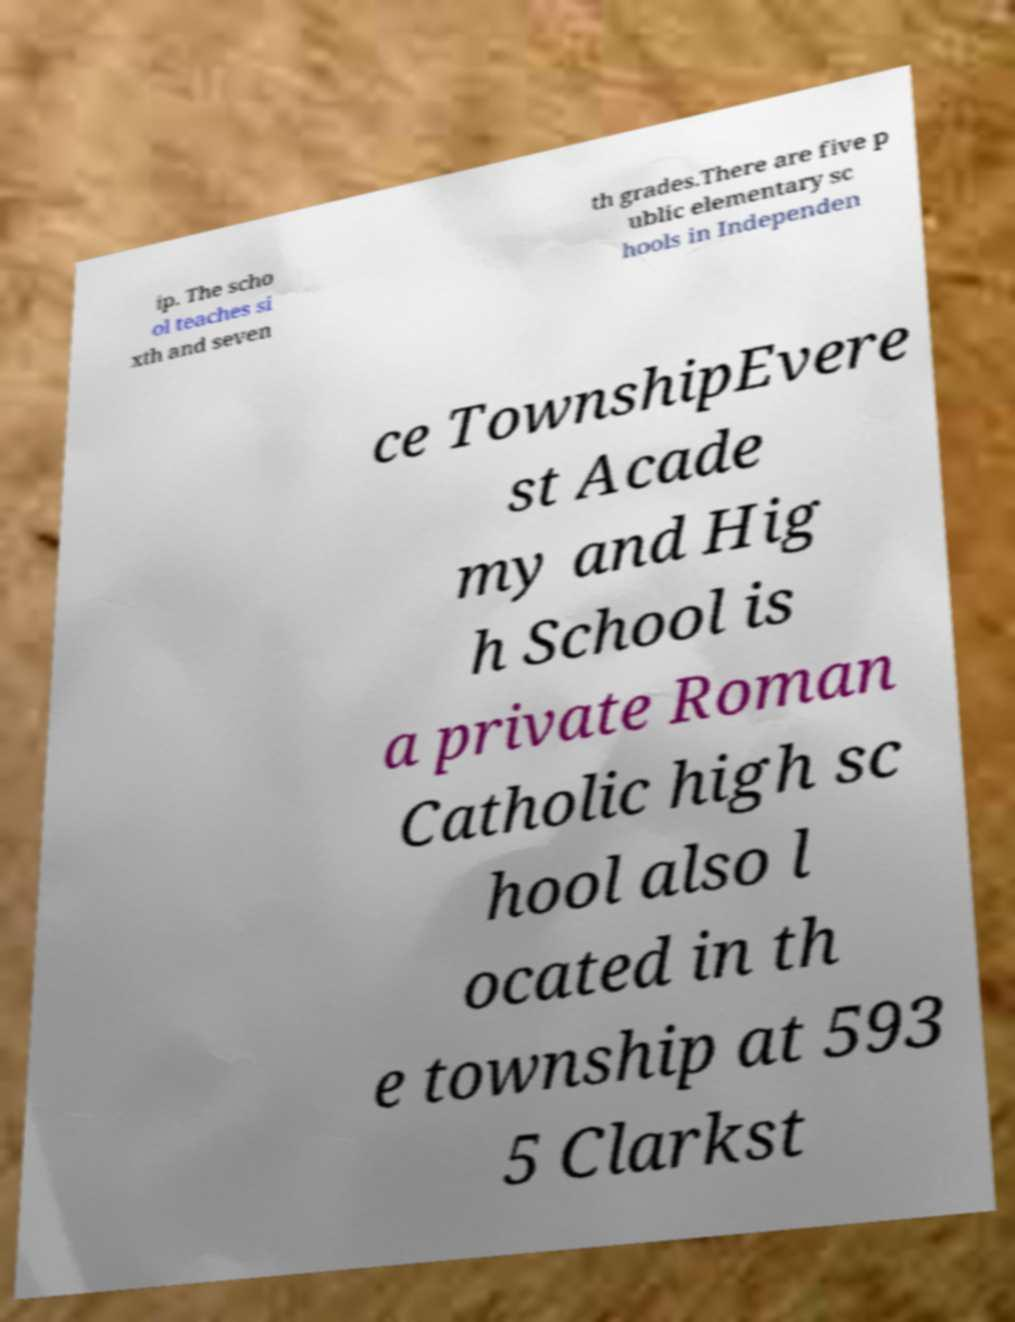Please read and relay the text visible in this image. What does it say? ip. The scho ol teaches si xth and seven th grades.There are five p ublic elementary sc hools in Independen ce TownshipEvere st Acade my and Hig h School is a private Roman Catholic high sc hool also l ocated in th e township at 593 5 Clarkst 